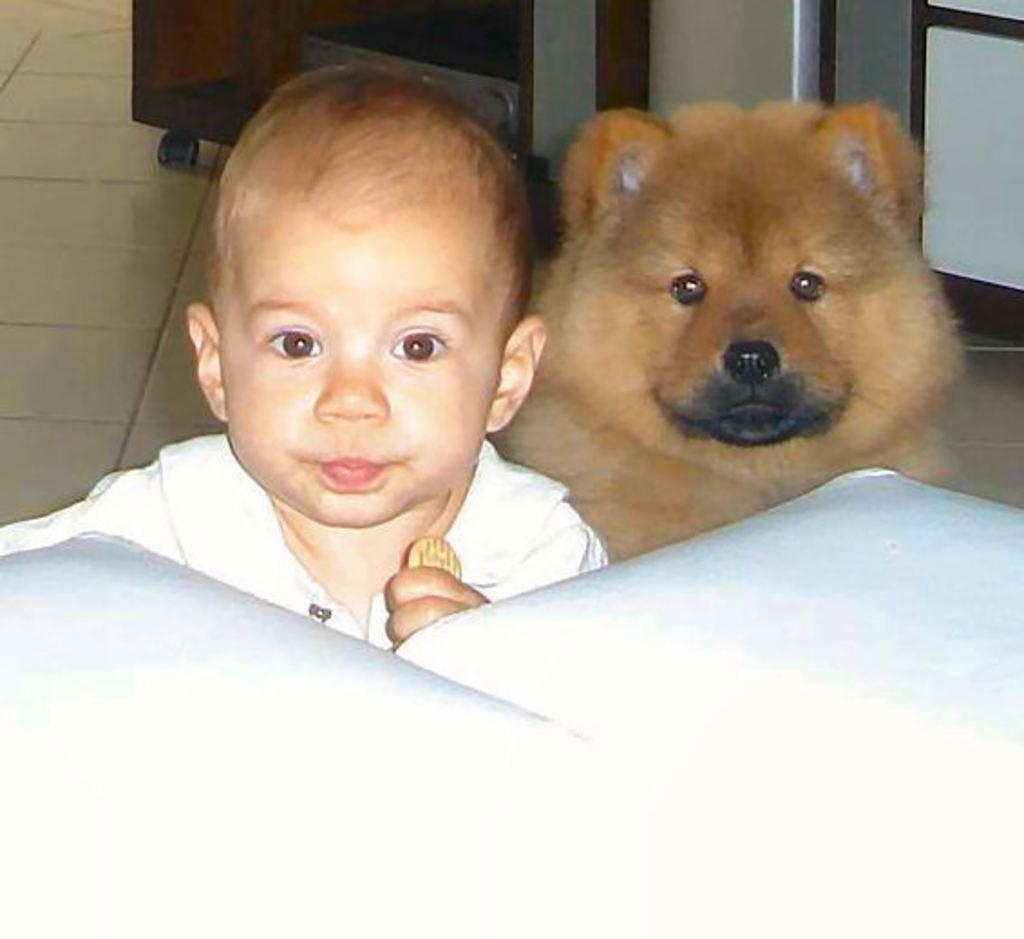What is the color of the object in the image? The object in the image is white. Who is present in the image? There is a boy and a dog in the image. What can be seen on the floor in the background of the image? There are objects visible on the floor in the background of the image. Can you see the minister standing next to the moon in the image? There is no minister or moon present in the image. Is the bat flying over the dog in the image? There is no bat present in the image. 